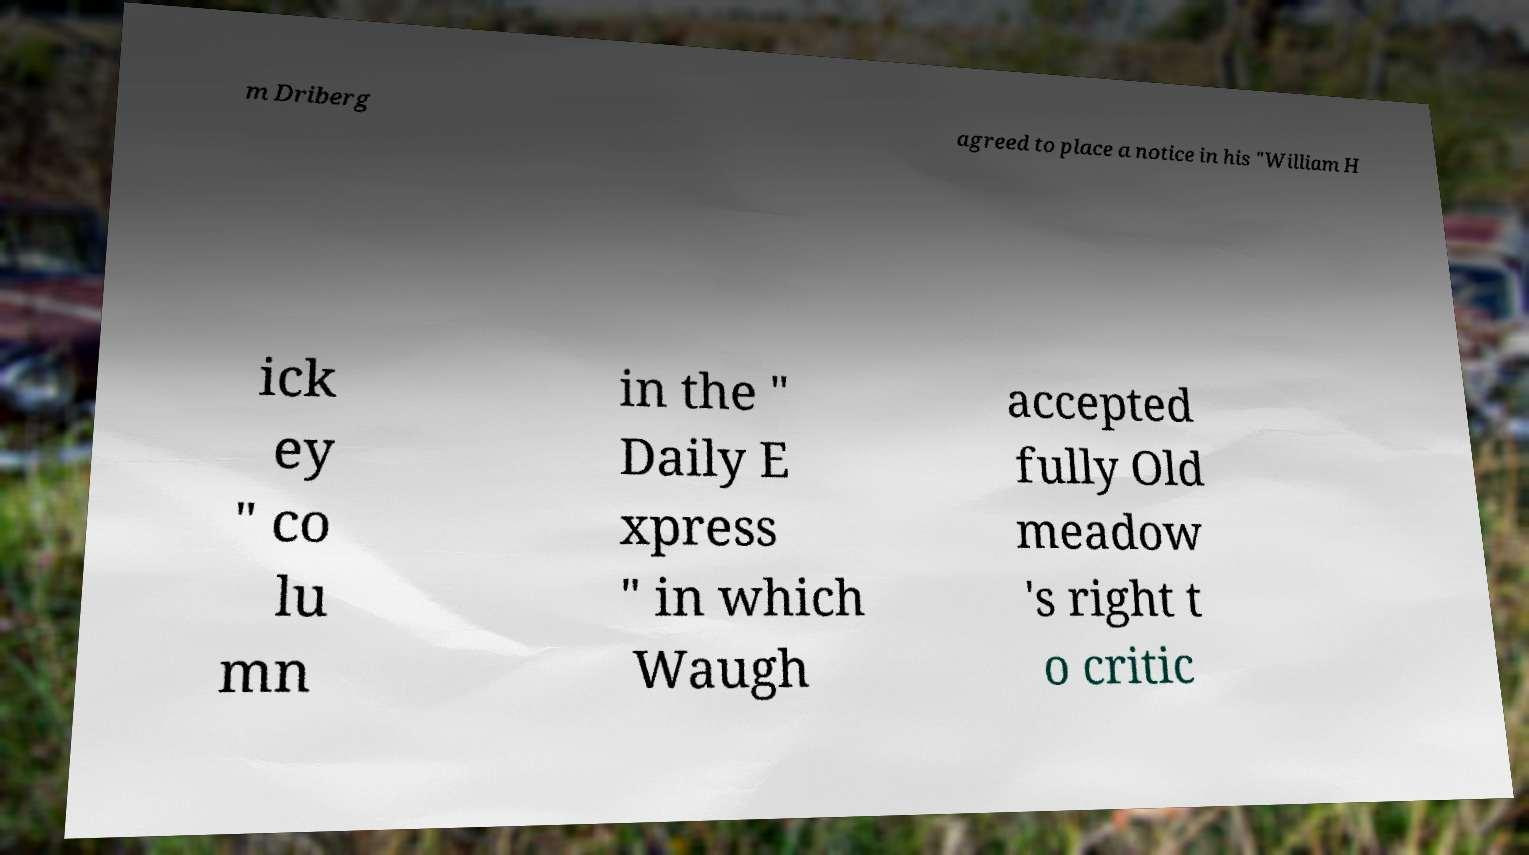Can you read and provide the text displayed in the image?This photo seems to have some interesting text. Can you extract and type it out for me? m Driberg agreed to place a notice in his "William H ick ey " co lu mn in the " Daily E xpress " in which Waugh accepted fully Old meadow 's right t o critic 